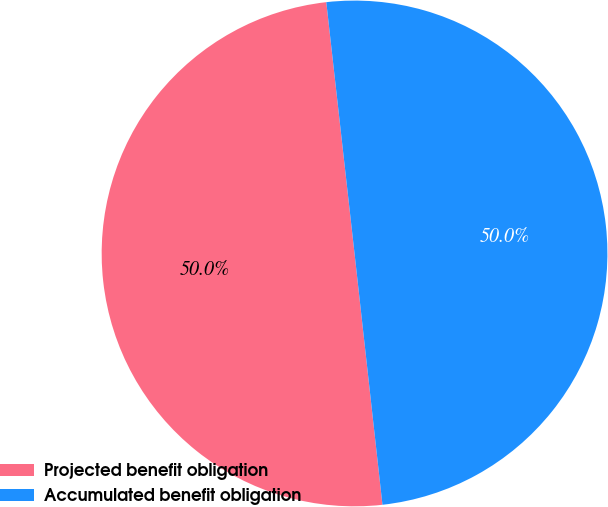Convert chart to OTSL. <chart><loc_0><loc_0><loc_500><loc_500><pie_chart><fcel>Projected benefit obligation<fcel>Accumulated benefit obligation<nl><fcel>49.98%<fcel>50.02%<nl></chart> 